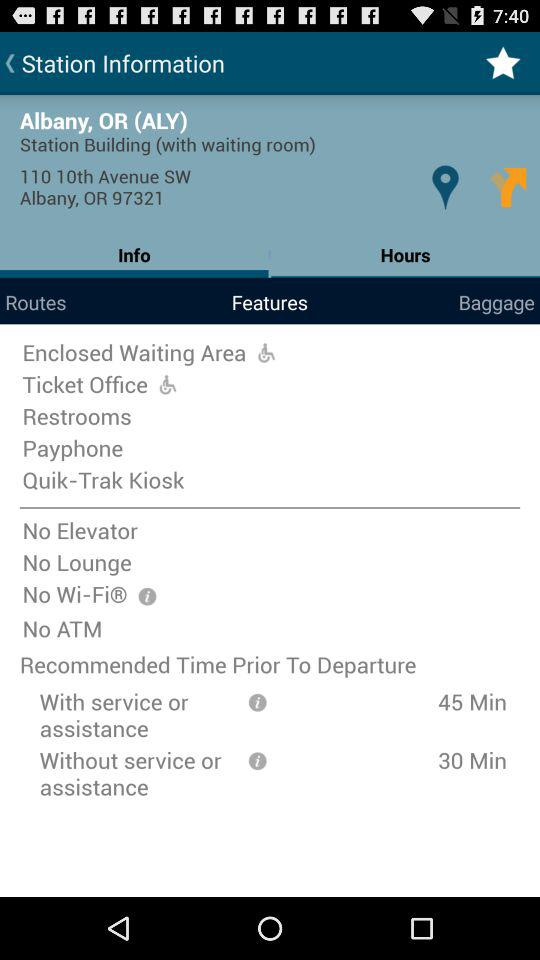How much time is recommended prior to departure with service or assistance? The recommended time is 45 minutes. 